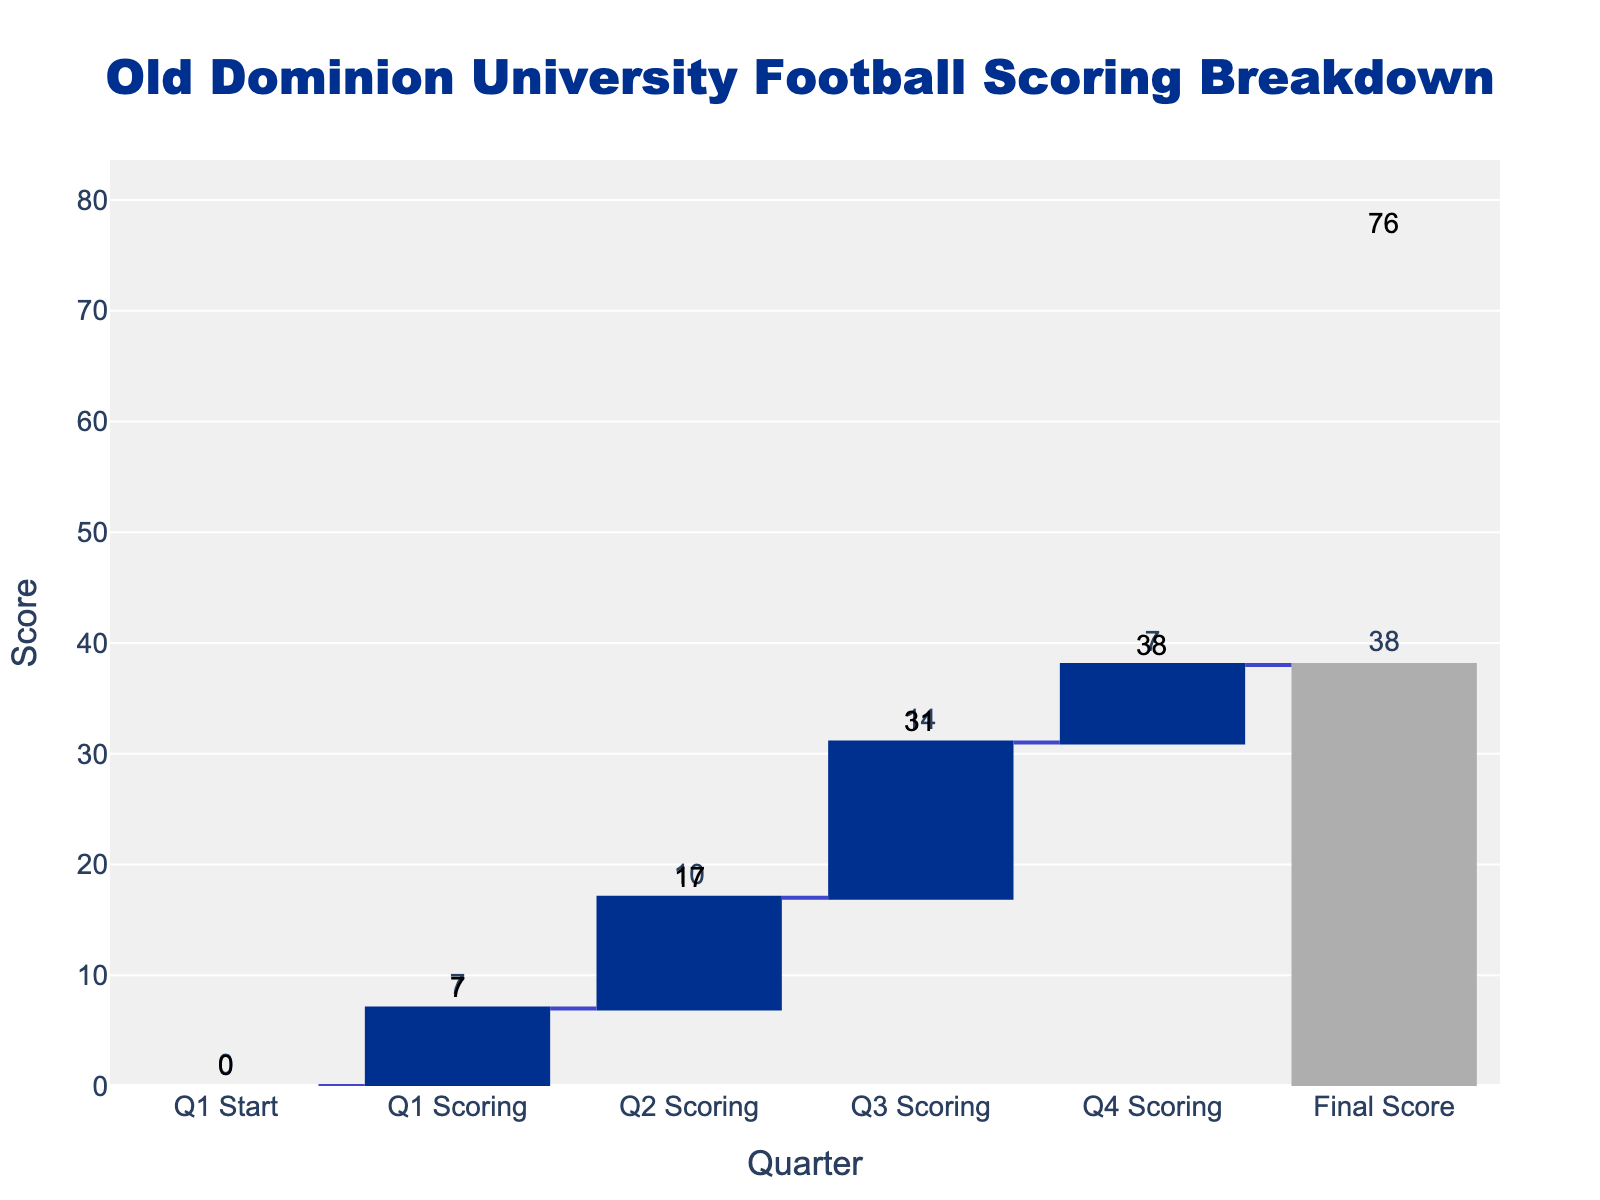What is the total final score for Old Dominion University in this game? The final score is shown at the top of the waterfall chart under "Final Score." The bar labeled "Final Score" sums up all the scores from each quarter, which is indicated as 38 points.
Answer: 38 How many points did Old Dominion University score in the third quarter? Look at the bar labeled "Q3 Scoring." The value at the top of the bar indicates how many points were scored in that quarter.
Answer: 14 What is the cumulative score at the end of the second quarter? To find the cumulative score at the end of the second quarter, sum the scores from the first and second quarters. The values are 7 (Q1) + 10 (Q2) = 17. This is visualized as the cumulative value at the end of the "Q2 Scoring" bar.
Answer: 17 During which quarter did Old Dominion University score the least number of points? Scan through the heights of the bars representing each quarter and identify the smallest bar. The "Q1 Scoring" and "Q4 Scoring" bars are both the smallest.
Answer: Q1 and Q4 What is the cumulative score after the third quarter? Sum all previous quarters' scores up to and including the third quarter: 7 (Q1) + 10 (Q2) + 14 (Q3) = 31. This cumulative score is indicated by the end of the "Q3 Scoring" bar.
Answer: 31 By how many points does the second quarter's score exceed the first quarter's? Subtract the first quarter's score from the second quarter's: 10 (Q2) - 7 (Q1) = 3.
Answer: 3 How do the first and fourth quarters' scores compare? Compare the values directly from the chart. Both "Q1 Scoring" and "Q4 Scoring" show a value of 7 points.
Answer: Equal What is the average score per quarter for Old Dominion University in this game? Add the scores for all quarters and divide by the number of quarters: (7 + 10 + 14 + 7) / 4 = 38 / 4 = 9.5.
Answer: 9.5 What's the difference between the highest and lowest scoring quarters? Identify the highest and lowest quarter scores, which are "Q3 Scoring" (14) and "Q1/Q4 Scoring" (7), respectively. Subtract: 14 - 7 = 7.
Answer: 7 